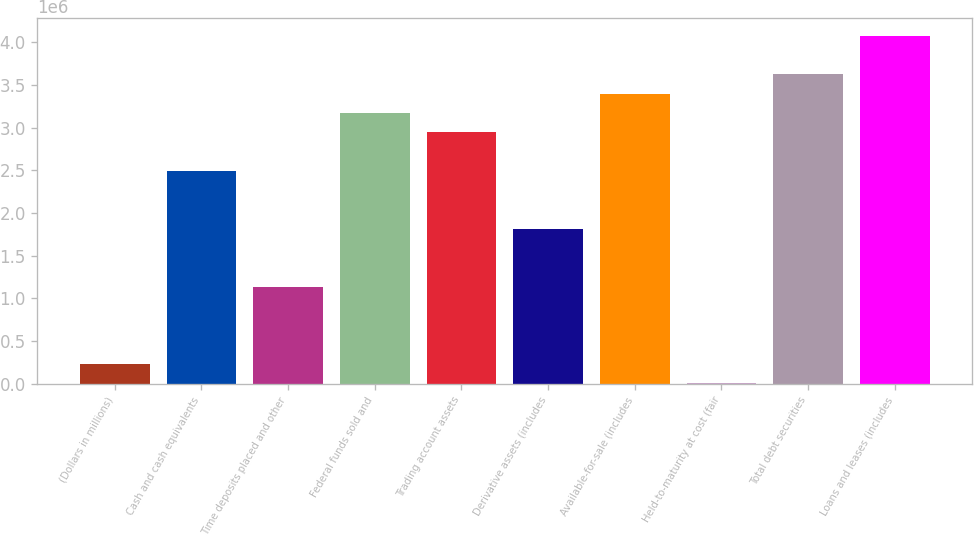<chart> <loc_0><loc_0><loc_500><loc_500><bar_chart><fcel>(Dollars in millions)<fcel>Cash and cash equivalents<fcel>Time deposits placed and other<fcel>Federal funds sold and<fcel>Trading account assets<fcel>Derivative assets (includes<fcel>Available-for-sale (includes<fcel>Held-to-maturity at cost (fair<fcel>Total debt securities<fcel>Loans and leases (includes<nl><fcel>226875<fcel>2.49136e+06<fcel>1.13267e+06<fcel>3.1707e+06<fcel>2.94425e+06<fcel>1.81201e+06<fcel>3.39715e+06<fcel>427<fcel>3.6236e+06<fcel>4.07649e+06<nl></chart> 